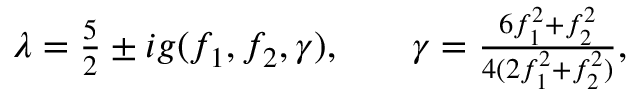Convert formula to latex. <formula><loc_0><loc_0><loc_500><loc_500>\begin{array} { r l r } { \lambda = \frac { 5 } { 2 } \pm i g ( f _ { 1 } , f _ { 2 } , \gamma ) , } & { \gamma = \frac { 6 f _ { 1 } ^ { 2 } + f _ { 2 } ^ { 2 } } { 4 ( 2 f _ { 1 } ^ { 2 } + f _ { 2 } ^ { 2 } ) } , } \end{array}</formula> 